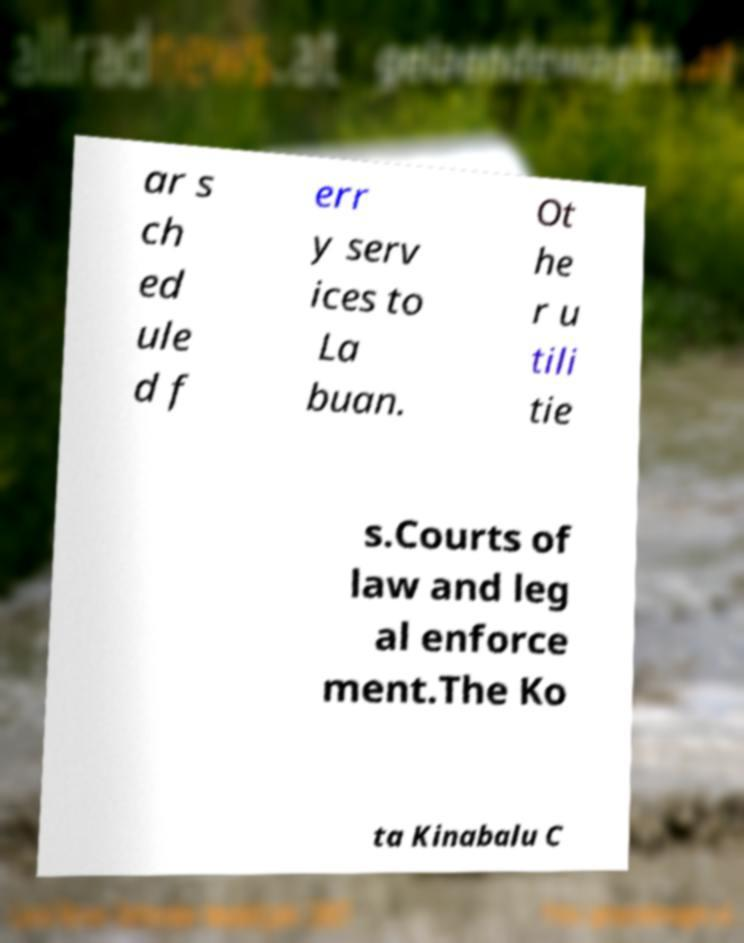Please identify and transcribe the text found in this image. ar s ch ed ule d f err y serv ices to La buan. Ot he r u tili tie s.Courts of law and leg al enforce ment.The Ko ta Kinabalu C 